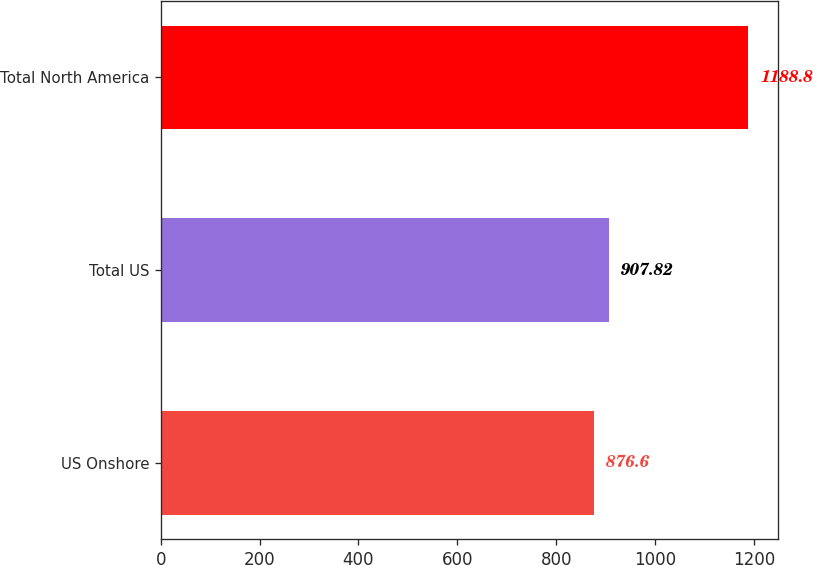<chart> <loc_0><loc_0><loc_500><loc_500><bar_chart><fcel>US Onshore<fcel>Total US<fcel>Total North America<nl><fcel>876.6<fcel>907.82<fcel>1188.8<nl></chart> 